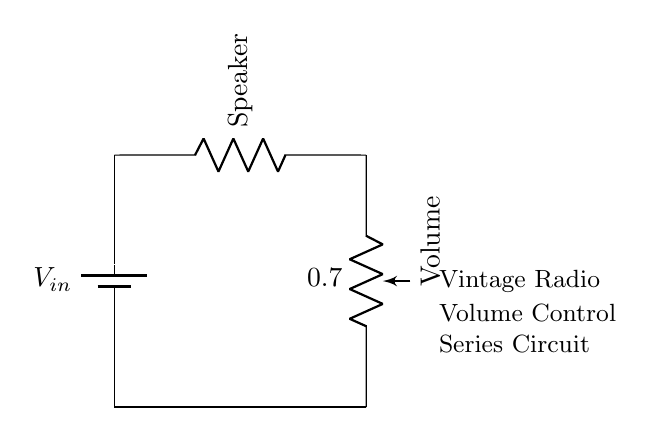What is the type of circuit shown? The circuit is a series circuit, which is characterized by a single path for the current to flow through all components.
Answer: Series circuit What component is used for volume control? The volume control in the circuit is implemented using a potentiometer, which allows adjustment of resistance and thus the volume level.
Answer: Potentiometer How many components are in the circuit? There are three main components in the circuit: a battery, a speaker, and a potentiometer.
Answer: Three What type of load does this circuit drive? The load being driven by this circuit is a speaker, which converts electrical energy into sound.
Answer: Speaker What happens to the current when the potentiometer is adjusted? Adjusting the potentiometer changes the resistance, which alters the current flowing through the circuit based on Ohm's Law, affecting the volume output.
Answer: Changes What is the role of the battery in this circuit? The battery serves as the power source, providing the necessary voltage for the operation of the radio circuit and driving the current through the components.
Answer: Power source If the potentiometer is set to maximum resistance, what happens to the sound? Setting the potentiometer to maximum resistance reduces the current to a minimum, causing the sound output to be very low or silent.
Answer: Silent 